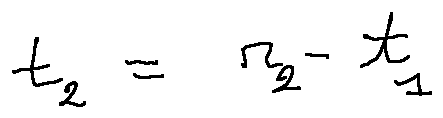<formula> <loc_0><loc_0><loc_500><loc_500>t _ { 2 } = r _ { 2 } - t _ { 1 }</formula> 